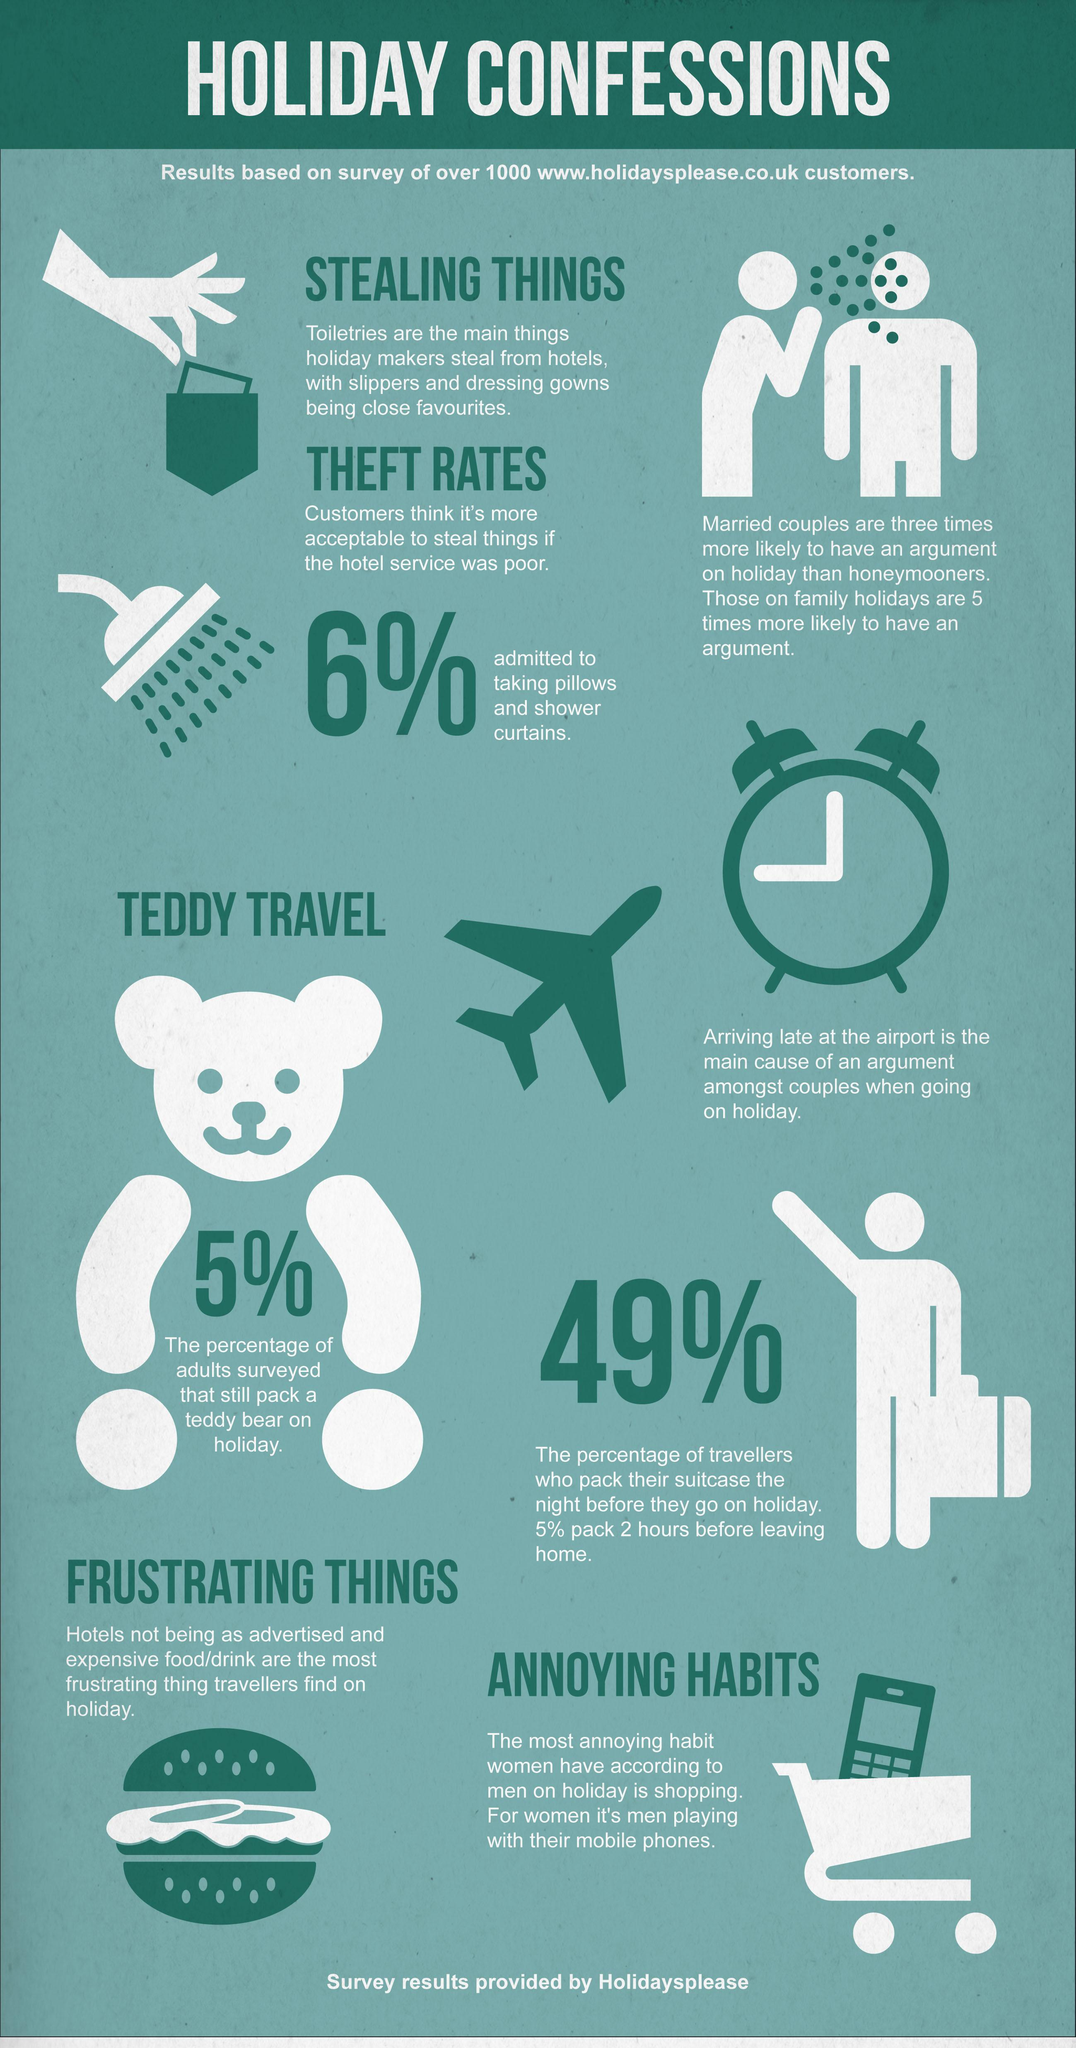Specify some key components in this picture. According to women, men often have annoying habits while on holiday, such as playing with their mobile phones excessively. The following images depict aeroplanes, with 1 being shown. Slippers and dressing gowns are the most commonly stolen toiletries by holidaymakers, according to recent statistics. The primary reason for arguments between couples on a holiday is when one or both parties arrive late at the airport. It is estimated that approximately 5% of adults carry their teddy bear with them on holiday. 